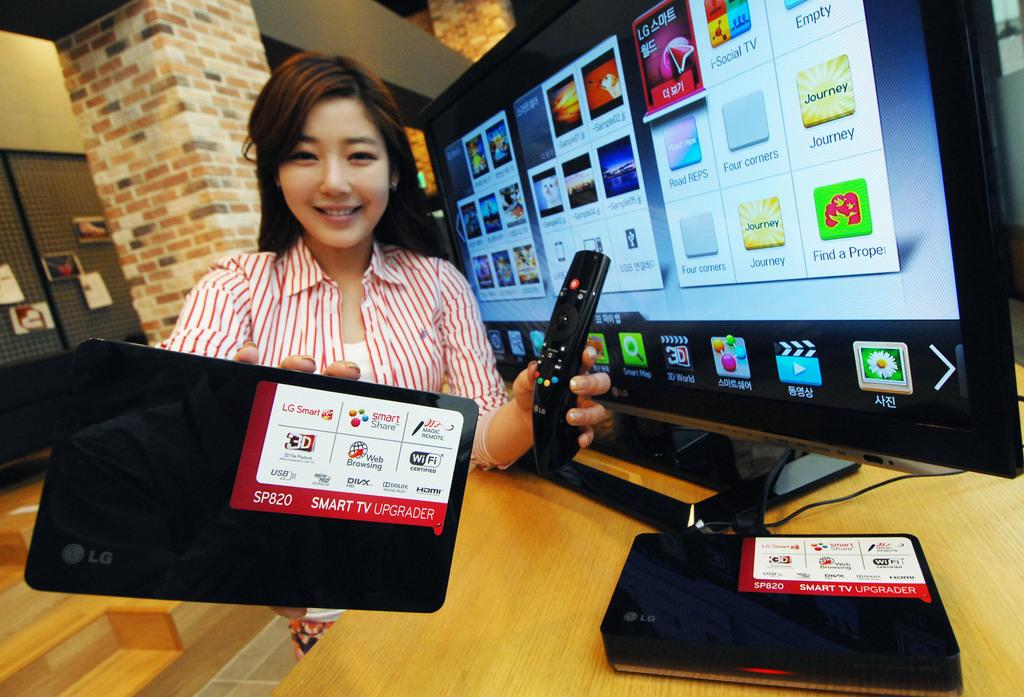<image>
Summarize the visual content of the image. A woman holds a SP820 smart TV upgrader in her right hand. 